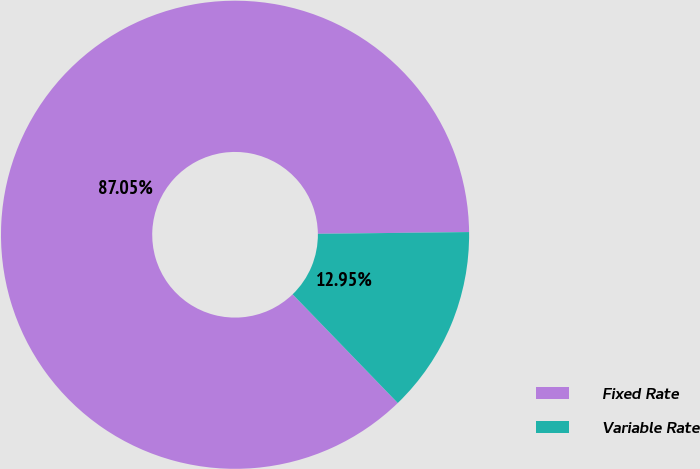Convert chart. <chart><loc_0><loc_0><loc_500><loc_500><pie_chart><fcel>Fixed Rate<fcel>Variable Rate<nl><fcel>87.05%<fcel>12.95%<nl></chart> 